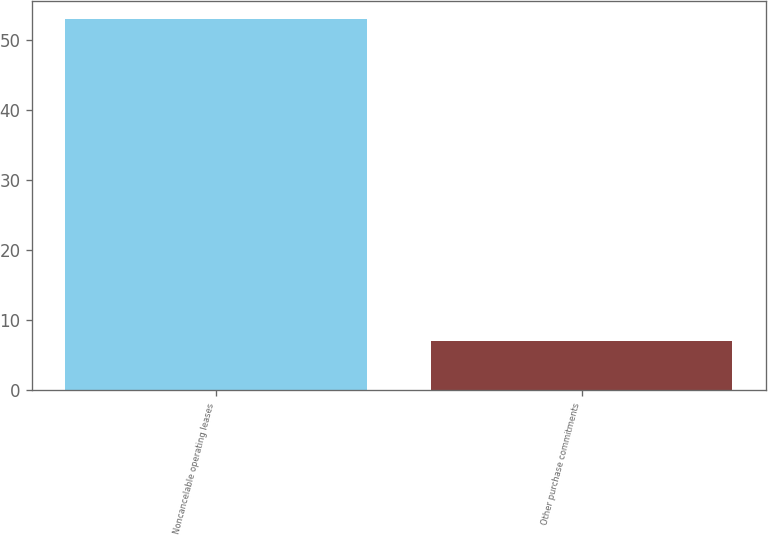<chart> <loc_0><loc_0><loc_500><loc_500><bar_chart><fcel>Noncancelable operating leases<fcel>Other purchase commitments<nl><fcel>53<fcel>7<nl></chart> 